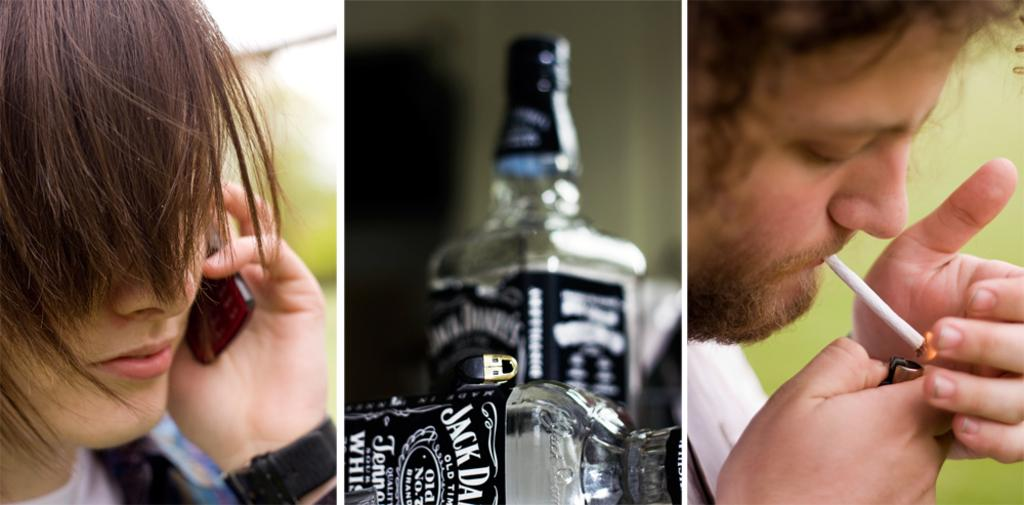<image>
Write a terse but informative summary of the picture. Bottle of Jack Daniels in center of woman on a cell phone and man lighting a cigarette. 